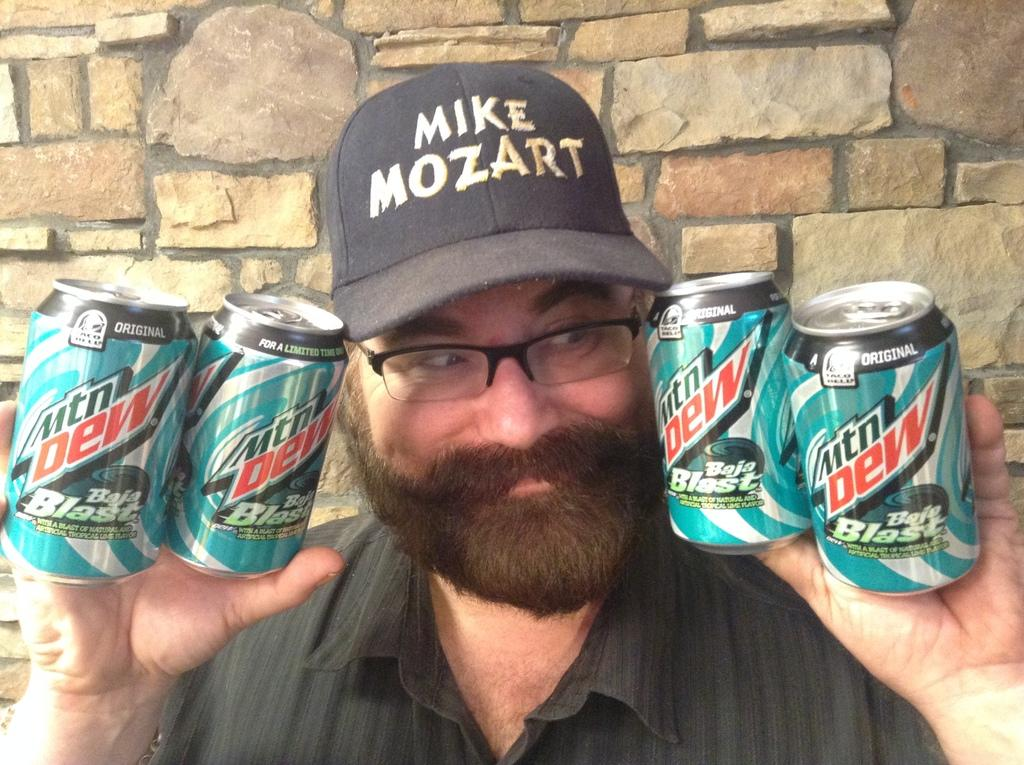<image>
Share a concise interpretation of the image provided. A man in a hat is grinning as he holds up four cans of Mtn Dew Baja Blast. 